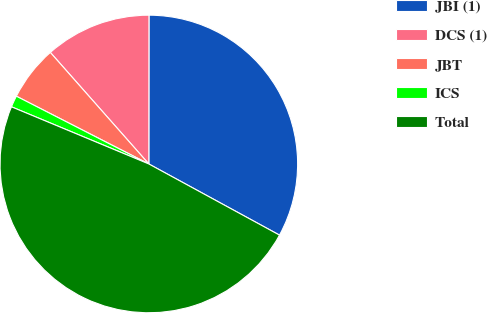Convert chart. <chart><loc_0><loc_0><loc_500><loc_500><pie_chart><fcel>JBI (1)<fcel>DCS (1)<fcel>JBT<fcel>ICS<fcel>Total<nl><fcel>32.92%<fcel>11.53%<fcel>5.96%<fcel>1.25%<fcel>48.34%<nl></chart> 